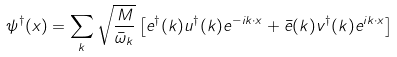<formula> <loc_0><loc_0><loc_500><loc_500>\psi ^ { \dagger } ( { x } ) = \sum _ { k } \sqrt { \frac { M } { \bar { \omega } _ { k } } } \left [ e ^ { \dagger } ( { k } ) u ^ { \dagger } ( { k } ) e ^ { - i { k \cdot x } } + \bar { e } ( { k } ) v ^ { \dagger } ( { k } ) e ^ { i { k \cdot x } } \right ]</formula> 